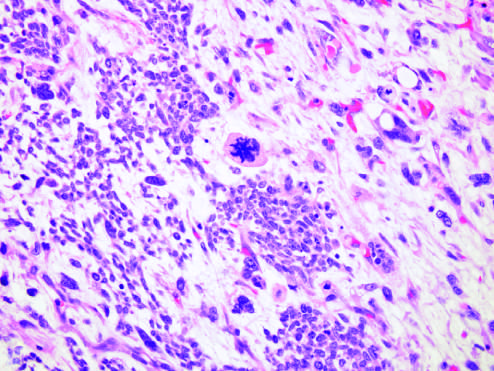was the extensive subcutaneous fibrosis present in other areas within this wilms tumor, characterized by cells with hyperchromatic, pleomorphic nuclei, and an abnormal mitosis center of field?
Answer the question using a single word or phrase. No 